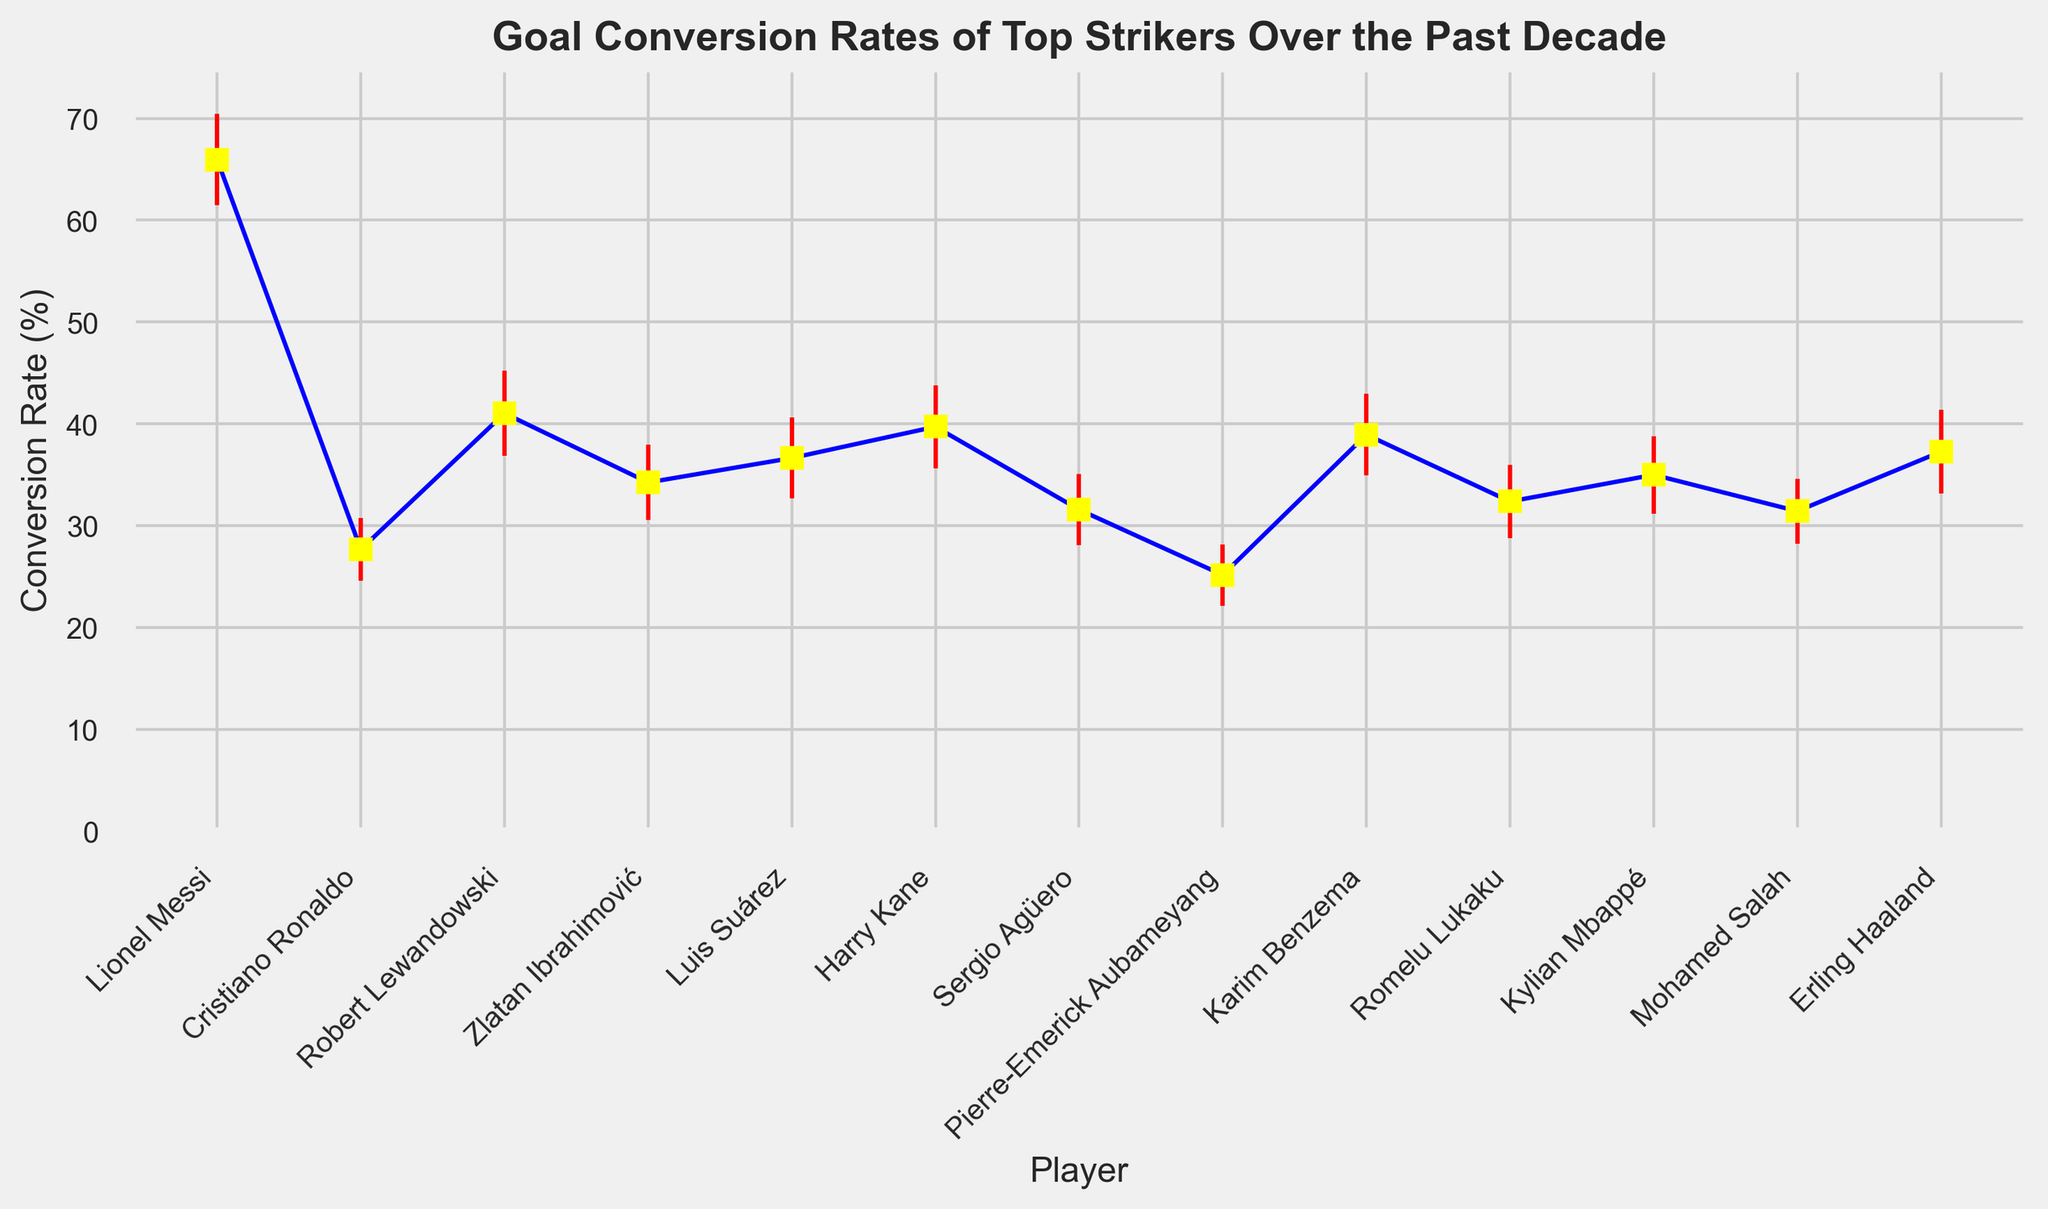Which player has the highest goal conversion rate in the past decade? Lionel Messi has the highest goal conversion rate. His error bar extends higher than any other player's, indicating the highest recorded performance.
Answer: Lionel Messi Which player has the lowest goal conversion rate, and what's the rate? Pierre-Emerick Aubameyang has the lowest goal conversion rate as his point is the lowest on the plot. The rate is around 25.16%.
Answer: Pierre-Emerick Aubameyang, 25.16% Compare the goal conversion rates of Lionel Messi and Cristiano Ronaldo; who performed better and by how much? Lionel Messi has a conversion rate of 65.94%, while Cristiano Ronaldo's rate is 27.68%. To find the difference, subtract Ronaldo's rate from Messi's (65.94 - 27.68 = 38.26). So, Messi performed better by 38.26%.
Answer: Lionel Messi, 38.26% Which player's goal conversion rate has the highest standard deviation? The vertical length of Lionel Messi's error bar appears the longest, indicating the highest standard deviation.
Answer: Lionel Messi Arrange the players in ascending order of their goal conversion rates. From the plot, the players' conversion rates in ascending order are: Pierre-Emerick Aubameyang, Cristiano Ronaldo, Sergio Agüero, Mohamed Salah, Romelu Lukaku, Zlatan Ibrahimović, Kylian Mbappé, Luis Suárez, Erling Haaland, Karim Benzema, Harry Kane, Robert Lewandowski, Lionel Messi.
Answer: Pierre-Emerick Aubameyang, Cristiano Ronaldo, Sergio Agüero, Mohamed Salah, Romelu Lukaku, Zlatan Ibrahimović, Kylian Mbappé, Luis Suárez, Erling Haaland, Karim Benzema, Harry Kane, Robert Lewandowski, Lionel Messi Which player has a conversion rate closest to 35% and what's the exact percentage? Kylian Mbappé has a conversion rate close to 35%. The plot shows a point exactly at this rate, confirming his performance.
Answer: Kylian Mbappé, 35% Compare the goal conversion rates of Robert Lewandowski and Harry Kane; who is more consistent, considering their standard deviation? Harry Kane has a conversion rate of 39.72% with a standard deviation of 4.1, while Robert Lewandowski has a rate of 41.04% with a standard deviation of 4.2. Given the slightly lower standard deviation, Kane is more consistent than Lewandowski.
Answer: Harry Kane Determine the average goal conversion rate of the players with standard deviations above 4.0. The players are Lionel Messi, Robert Lewandowski, Luis Suárez, Karim Benzema, and Erling Haaland. Their conversion rates are 65.94%, 41.04%, 36.65%, 38.94%, and 37.27%. Summing these gives 219.84 and the count is 5. So, the average is 219.84 / 5 = 43.968%.
Answer: 43.97% What is the median goal conversion rate of all the players? Arranging the conversion rates in order: 25.16, 27.68, 31.43, 31.58, 32.38, 34.25, 35, 36.65, 37.27, 38.94, 39.72, 41.04, 65.94, the median is the middle value, which is between 34.25 and 35, i.e., (34.25 + 35) / 2 = 34.625%.
Answer: 34.625% 